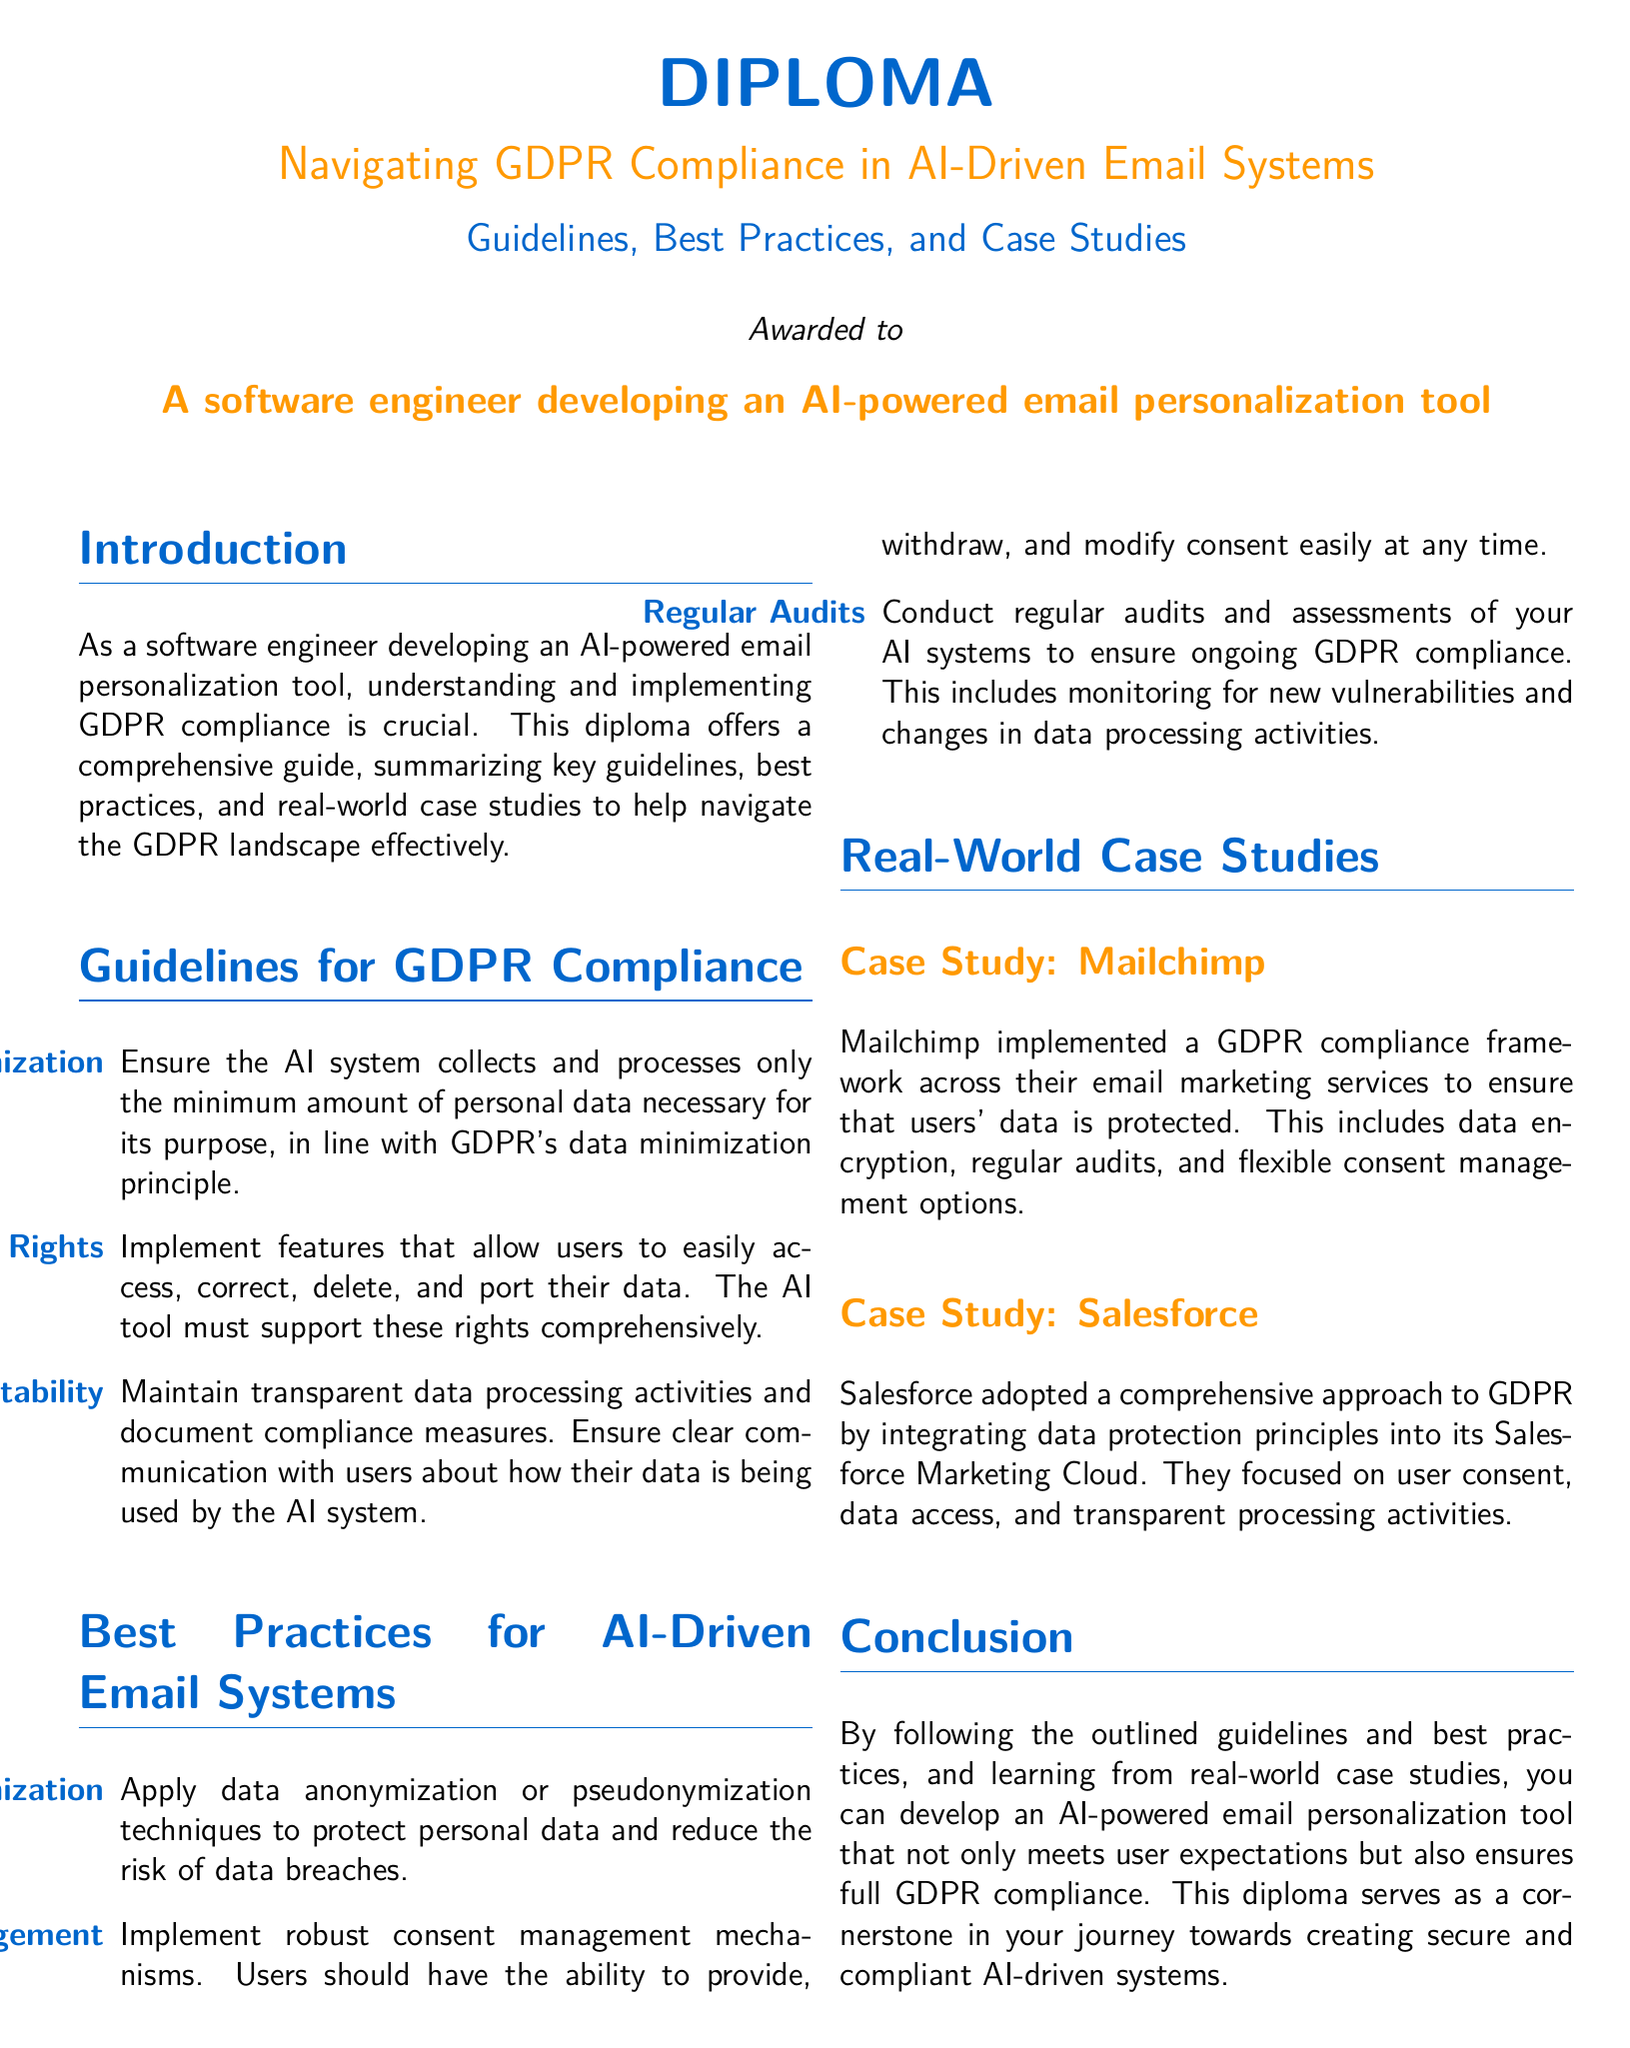What is the title of the diploma? The title is displayed prominently at the top of the document, stating the focus of the diploma.
Answer: Navigating GDPR Compliance in AI-Driven Email Systems Who is the diploma awarded to? The diploma clearly states the recipient, indicating the specific audience for the guidelines.
Answer: A software engineer developing an AI-powered email personalization tool What is one of the guidelines for GDPR compliance? The document lists several specific guidelines for GDPR compliance relevant to AI systems.
Answer: Data Minimization What is a key best practice mentioned for AI-driven email systems? The best practices section outlines recommended actions to be taken for compliance with GDPR.
Answer: Consent Management What company is mentioned in a case study? The case study section provides examples of organizations that have implemented GDPR compliance strategies.
Answer: Mailchimp How many main sections are there in the document? The document is structured with multiple sections that categorize information distinctly.
Answer: Four What is the focus of the conclusion? The conclusion summarizes the importance of adherence to guidelines and learning from case studies.
Answer: GDPR compliance What data protection technique is highlighted in best practices? Highlighted techniques in the best practices aim to enhance data security within AI-driven systems.
Answer: Data Anonymization and Pseudonymization What is the color scheme of the document? The document uses specific colors for titles and text to create a visual identity.
Answer: Main color and second color 